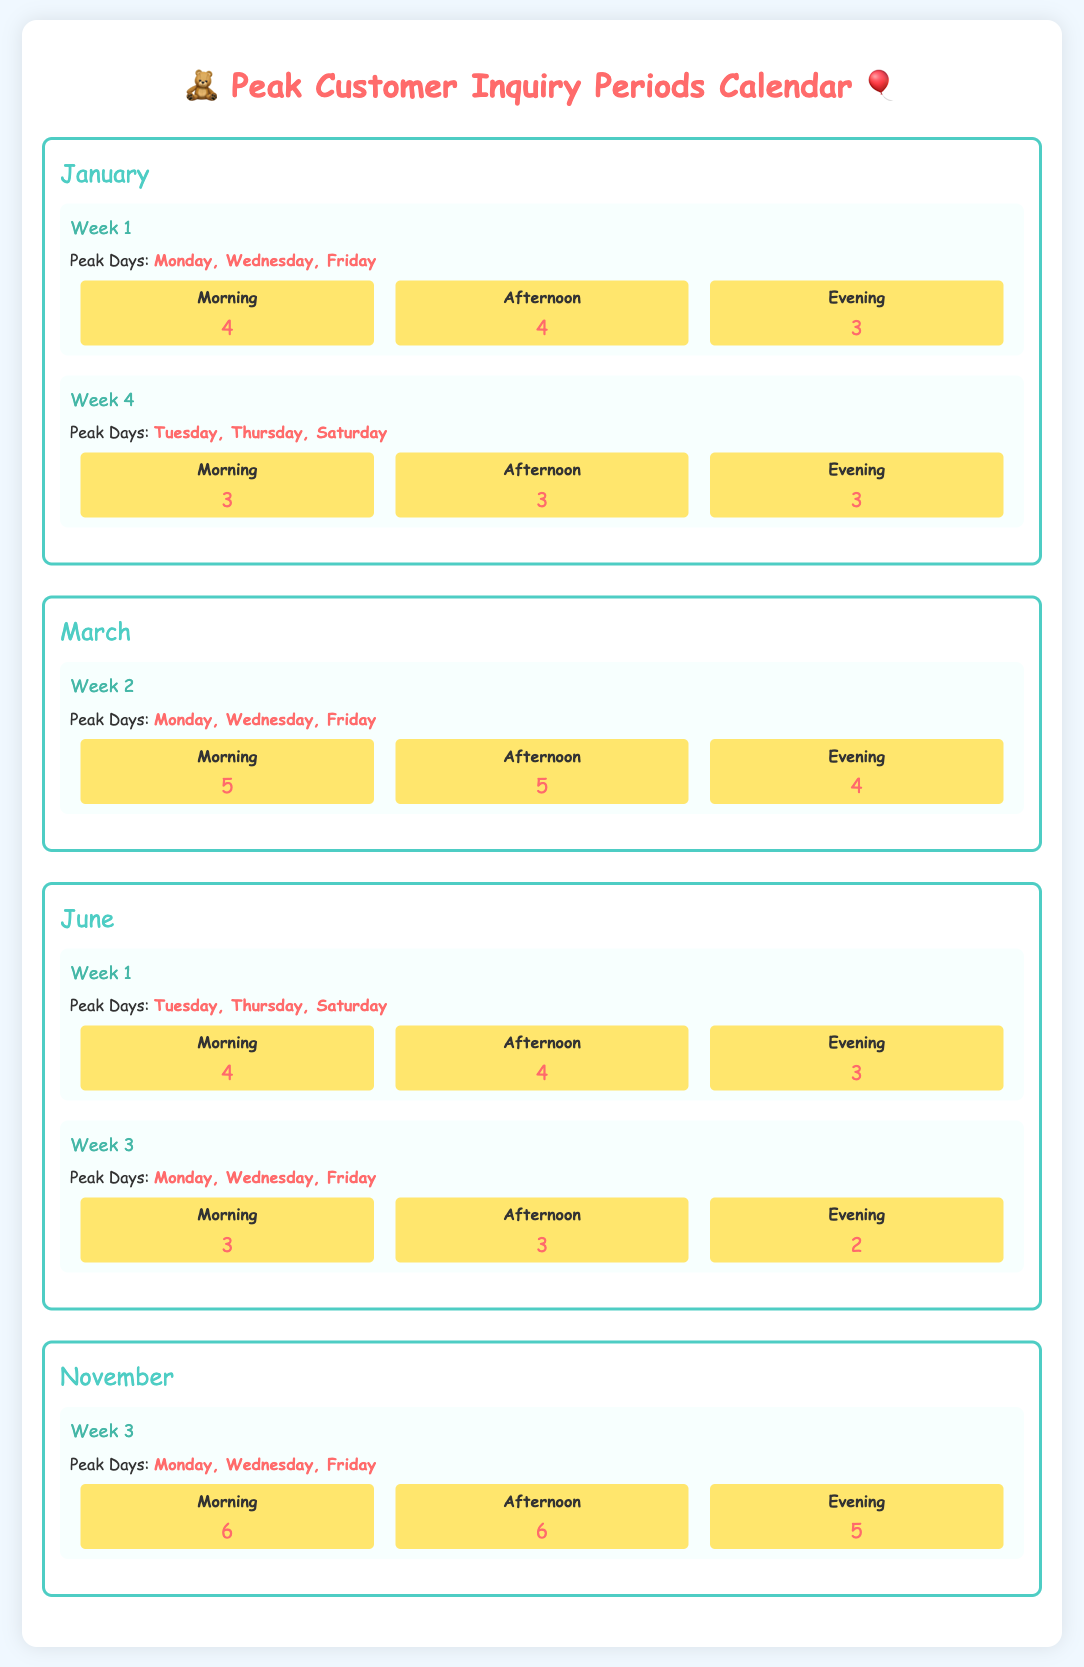What are the peak days in January for Week 1? The peak days in January for Week 1 are specified in the document.
Answer: Monday, Wednesday, Friday How many staff are required for the evening shift in November, Week 3? The staffing level for the evening shift in November, Week 3 is provided in the document.
Answer: 5 What is the total number of staff required for the morning shift in March, Week 2? The number of staff for the morning shift in March, Week 2 is listed in the document.
Answer: 5 Which month has peak days on Tuesday, Thursday, and Saturday during Week 1? The document specifies the peak days for each month and week.
Answer: June What is the staffing level for the afternoon shift in January, Week 4? The document includes specific staffing levels for each shift in the mentioned week.
Answer: 3 Which week in June has the highest number of staff in the evening shift? This question requires comparing the staffing levels in the evening shift across the weeks in June.
Answer: Week 1 How many total peak days are indicated for all months? The total number of peak days is derived from the data in the document.
Answer: 12 What color is used for the header of the calendar? The document describes the styling elements used for the calendar header.
Answer: Pink During which weeks in March are Mondays peak days? The reasoning will involve finding out which weeks in March have Mondays as peak days.
Answer: Week 2 